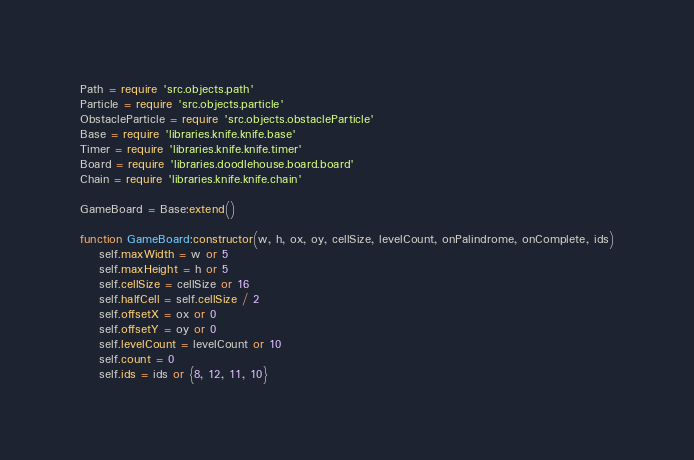Convert code to text. <code><loc_0><loc_0><loc_500><loc_500><_Lua_>Path = require 'src.objects.path'
Particle = require 'src.objects.particle'
ObstacleParticle = require 'src.objects.obstacleParticle'
Base = require 'libraries.knife.knife.base'
Timer = require 'libraries.knife.knife.timer'
Board = require 'libraries.doodlehouse.board.board'
Chain = require 'libraries.knife.knife.chain'

GameBoard = Base:extend()

function GameBoard:constructor(w, h, ox, oy, cellSize, levelCount, onPalindrome, onComplete, ids)
    self.maxWidth = w or 5
    self.maxHeight = h or 5
    self.cellSize = cellSize or 16
    self.halfCell = self.cellSize / 2
    self.offsetX = ox or 0
    self.offsetY = oy or 0
    self.levelCount = levelCount or 10
    self.count = 0
    self.ids = ids or {8, 12, 11, 10}</code> 